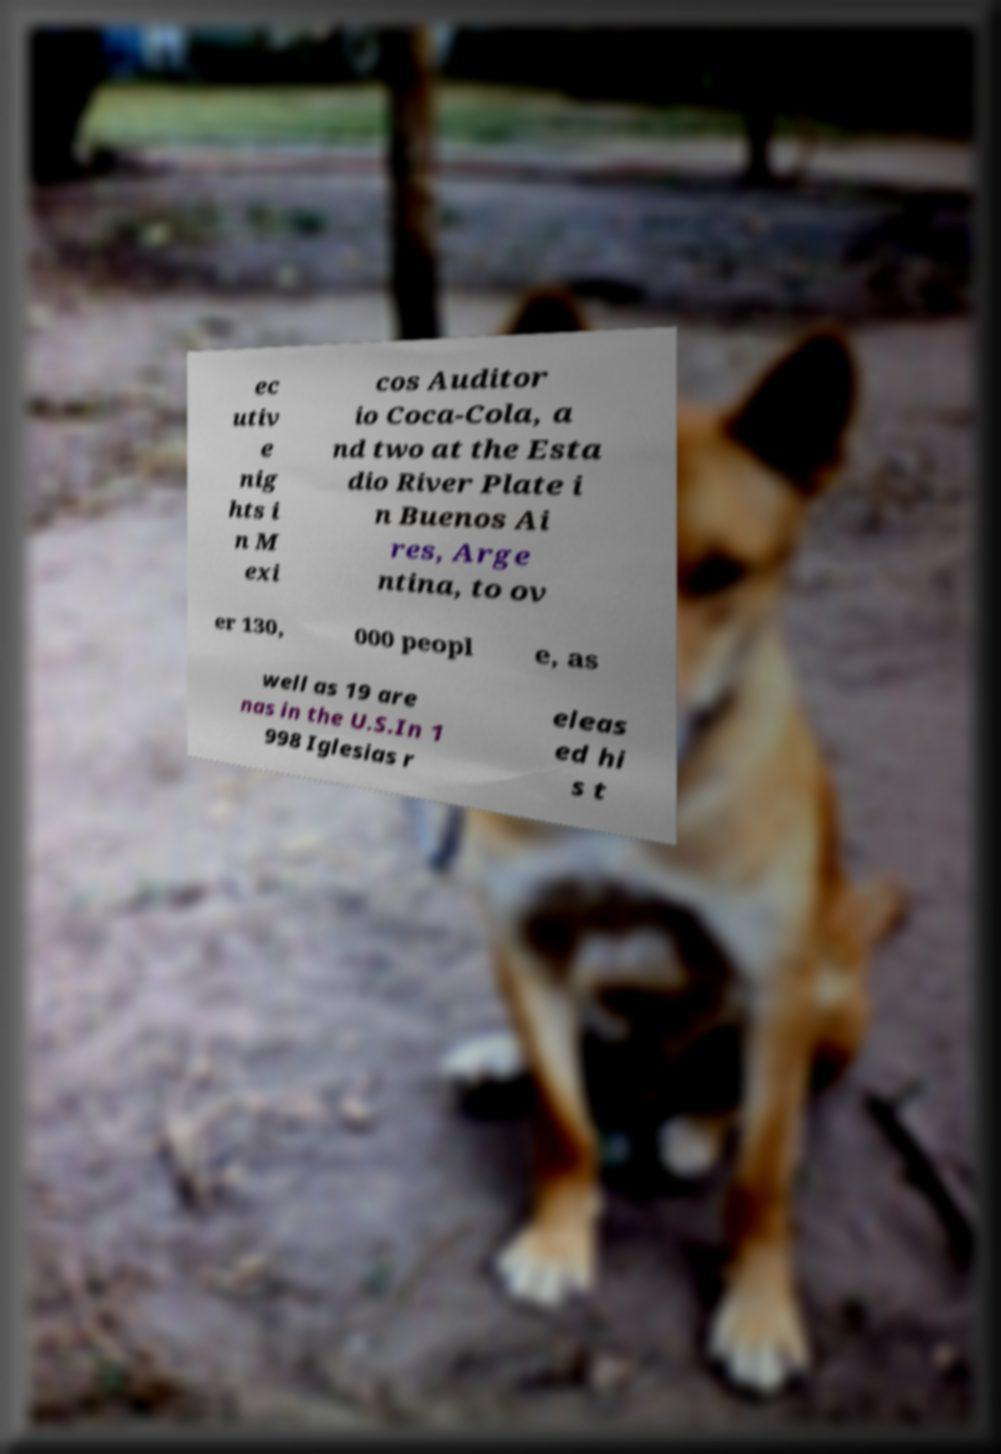I need the written content from this picture converted into text. Can you do that? ec utiv e nig hts i n M exi cos Auditor io Coca-Cola, a nd two at the Esta dio River Plate i n Buenos Ai res, Arge ntina, to ov er 130, 000 peopl e, as well as 19 are nas in the U.S.In 1 998 Iglesias r eleas ed hi s t 